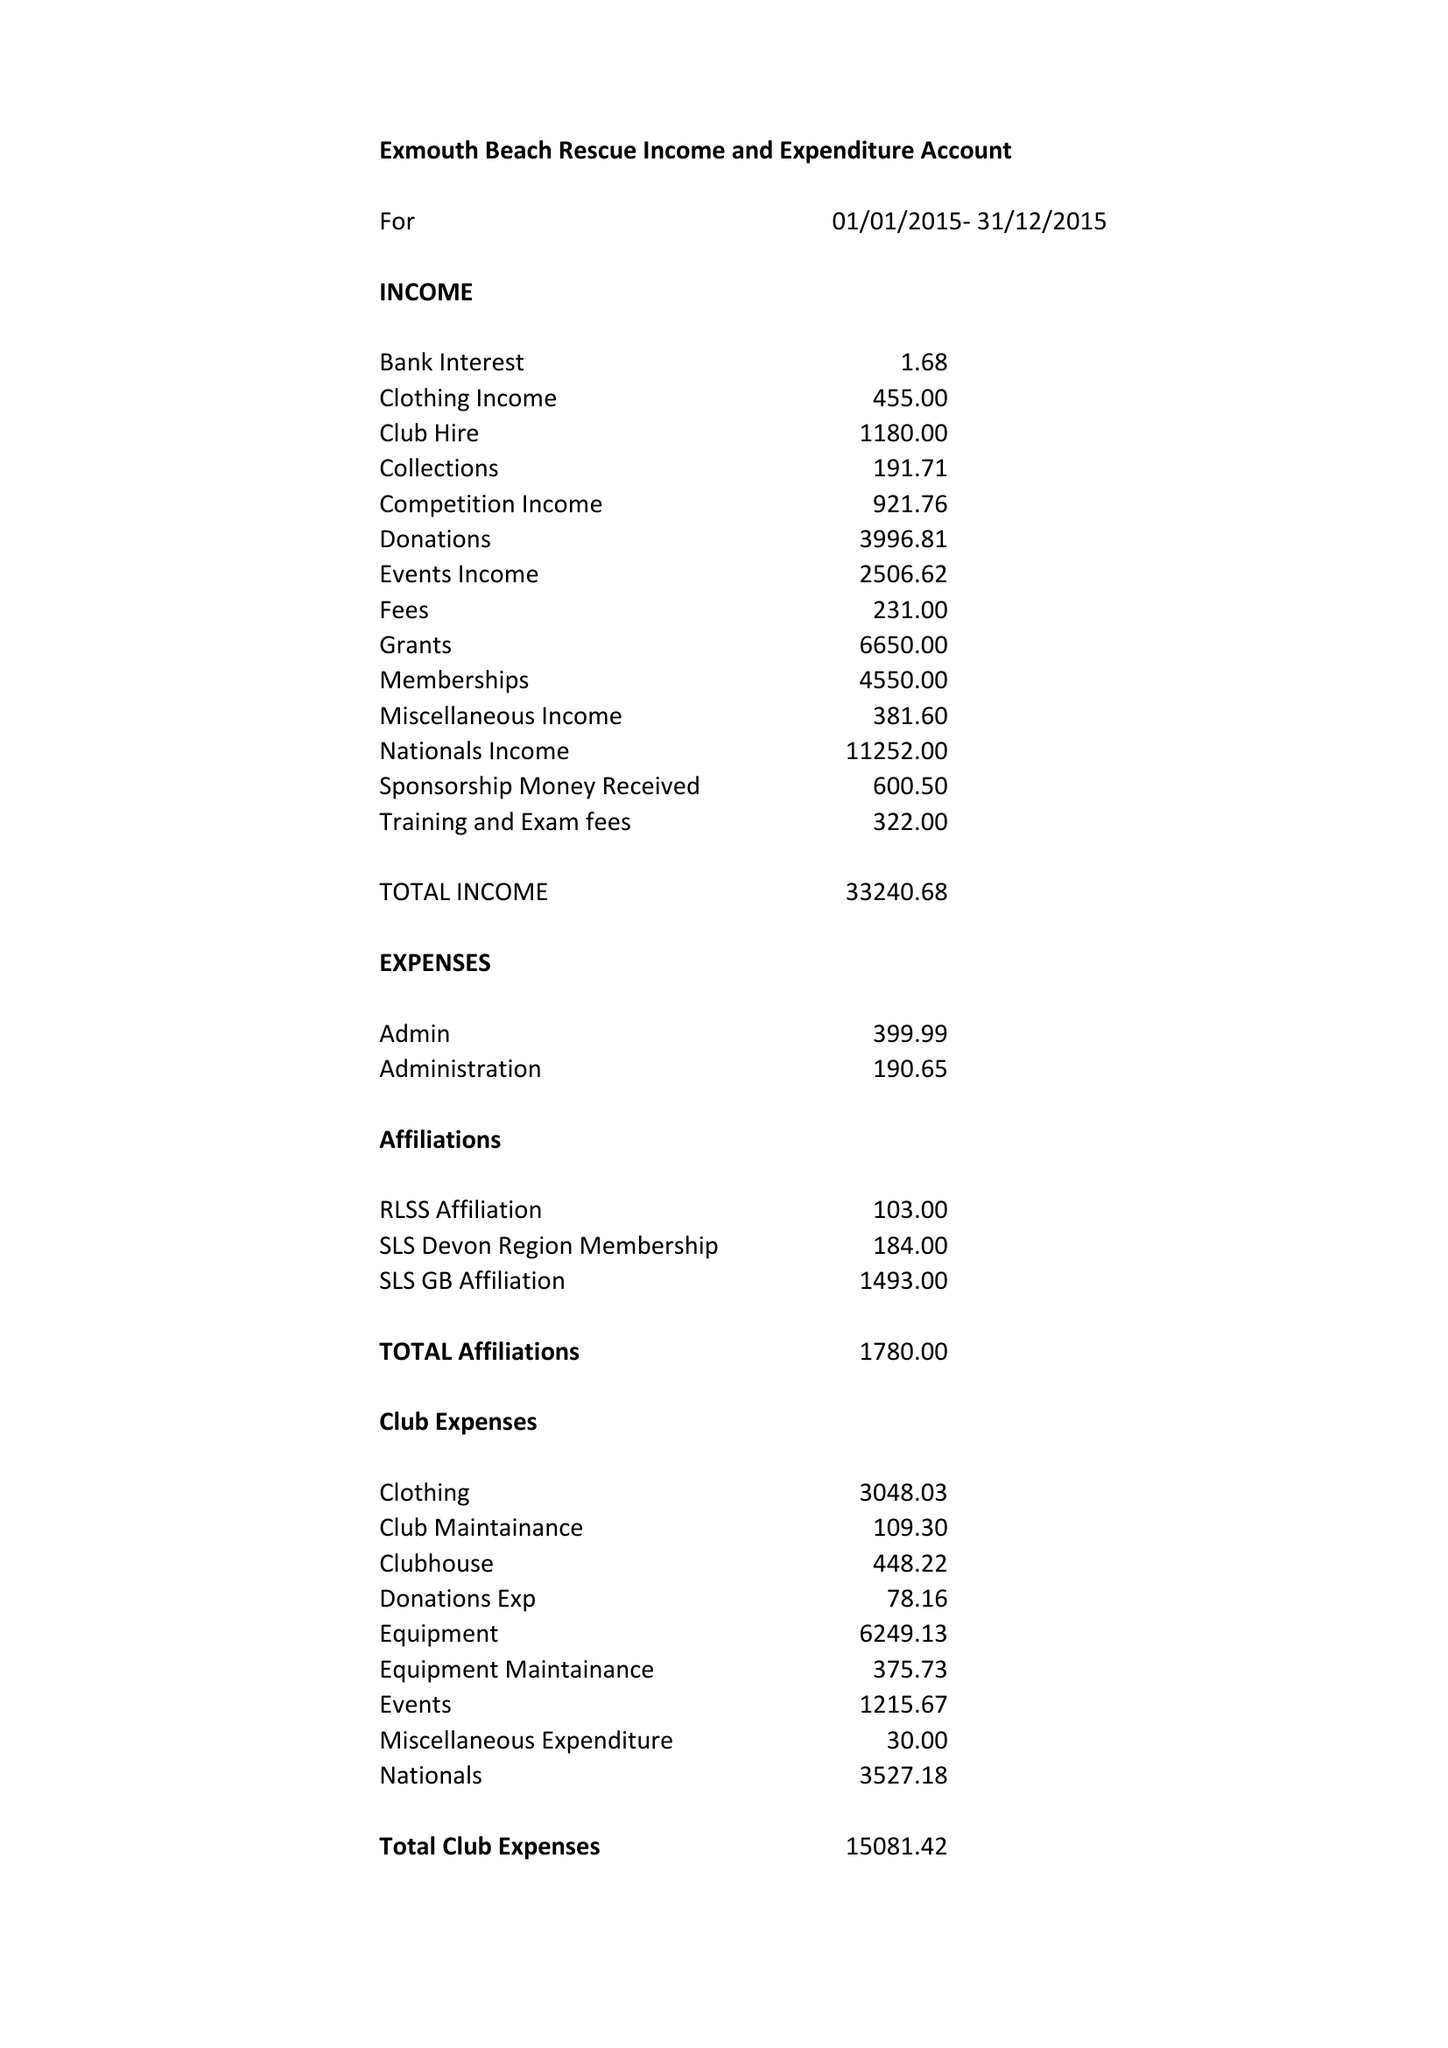What is the value for the address__postcode?
Answer the question using a single word or phrase. EX8 4JQ 